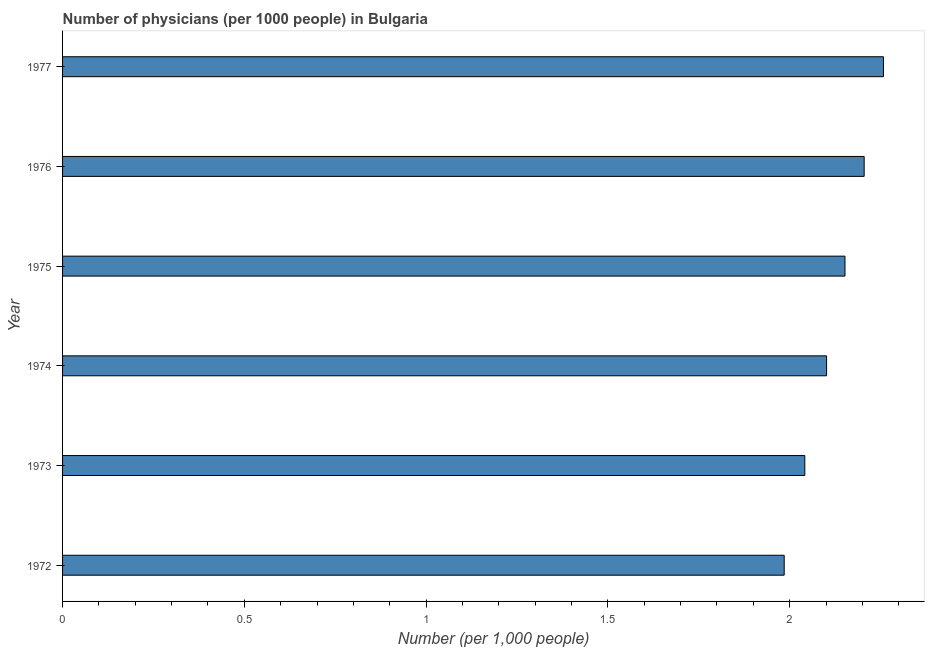What is the title of the graph?
Make the answer very short. Number of physicians (per 1000 people) in Bulgaria. What is the label or title of the X-axis?
Your answer should be compact. Number (per 1,0 people). What is the label or title of the Y-axis?
Your answer should be compact. Year. What is the number of physicians in 1973?
Your answer should be compact. 2.04. Across all years, what is the maximum number of physicians?
Give a very brief answer. 2.26. Across all years, what is the minimum number of physicians?
Your answer should be compact. 1.98. In which year was the number of physicians maximum?
Your answer should be compact. 1977. In which year was the number of physicians minimum?
Your answer should be very brief. 1972. What is the sum of the number of physicians?
Offer a very short reply. 12.74. What is the difference between the number of physicians in 1973 and 1974?
Your answer should be very brief. -0.06. What is the average number of physicians per year?
Keep it short and to the point. 2.12. What is the median number of physicians?
Offer a terse response. 2.13. What is the ratio of the number of physicians in 1972 to that in 1974?
Offer a very short reply. 0.94. Is the difference between the number of physicians in 1973 and 1977 greater than the difference between any two years?
Keep it short and to the point. No. What is the difference between the highest and the second highest number of physicians?
Offer a terse response. 0.05. What is the difference between the highest and the lowest number of physicians?
Give a very brief answer. 0.27. How many bars are there?
Give a very brief answer. 6. Are all the bars in the graph horizontal?
Your answer should be compact. Yes. What is the Number (per 1,000 people) in 1972?
Your answer should be very brief. 1.98. What is the Number (per 1,000 people) of 1973?
Your answer should be compact. 2.04. What is the Number (per 1,000 people) of 1974?
Keep it short and to the point. 2.1. What is the Number (per 1,000 people) in 1975?
Provide a short and direct response. 2.15. What is the Number (per 1,000 people) of 1976?
Make the answer very short. 2.2. What is the Number (per 1,000 people) in 1977?
Provide a short and direct response. 2.26. What is the difference between the Number (per 1,000 people) in 1972 and 1973?
Ensure brevity in your answer.  -0.06. What is the difference between the Number (per 1,000 people) in 1972 and 1974?
Your response must be concise. -0.12. What is the difference between the Number (per 1,000 people) in 1972 and 1975?
Give a very brief answer. -0.17. What is the difference between the Number (per 1,000 people) in 1972 and 1976?
Provide a short and direct response. -0.22. What is the difference between the Number (per 1,000 people) in 1972 and 1977?
Your response must be concise. -0.27. What is the difference between the Number (per 1,000 people) in 1973 and 1974?
Offer a very short reply. -0.06. What is the difference between the Number (per 1,000 people) in 1973 and 1975?
Provide a succinct answer. -0.11. What is the difference between the Number (per 1,000 people) in 1973 and 1976?
Ensure brevity in your answer.  -0.16. What is the difference between the Number (per 1,000 people) in 1973 and 1977?
Your answer should be compact. -0.22. What is the difference between the Number (per 1,000 people) in 1974 and 1975?
Give a very brief answer. -0.05. What is the difference between the Number (per 1,000 people) in 1974 and 1976?
Offer a terse response. -0.1. What is the difference between the Number (per 1,000 people) in 1974 and 1977?
Offer a very short reply. -0.16. What is the difference between the Number (per 1,000 people) in 1975 and 1976?
Ensure brevity in your answer.  -0.05. What is the difference between the Number (per 1,000 people) in 1975 and 1977?
Ensure brevity in your answer.  -0.11. What is the difference between the Number (per 1,000 people) in 1976 and 1977?
Make the answer very short. -0.05. What is the ratio of the Number (per 1,000 people) in 1972 to that in 1974?
Keep it short and to the point. 0.94. What is the ratio of the Number (per 1,000 people) in 1972 to that in 1975?
Give a very brief answer. 0.92. What is the ratio of the Number (per 1,000 people) in 1972 to that in 1977?
Ensure brevity in your answer.  0.88. What is the ratio of the Number (per 1,000 people) in 1973 to that in 1974?
Give a very brief answer. 0.97. What is the ratio of the Number (per 1,000 people) in 1973 to that in 1975?
Keep it short and to the point. 0.95. What is the ratio of the Number (per 1,000 people) in 1973 to that in 1976?
Offer a very short reply. 0.93. What is the ratio of the Number (per 1,000 people) in 1973 to that in 1977?
Ensure brevity in your answer.  0.9. What is the ratio of the Number (per 1,000 people) in 1974 to that in 1976?
Your response must be concise. 0.95. What is the ratio of the Number (per 1,000 people) in 1974 to that in 1977?
Your answer should be compact. 0.93. What is the ratio of the Number (per 1,000 people) in 1975 to that in 1977?
Keep it short and to the point. 0.95. 